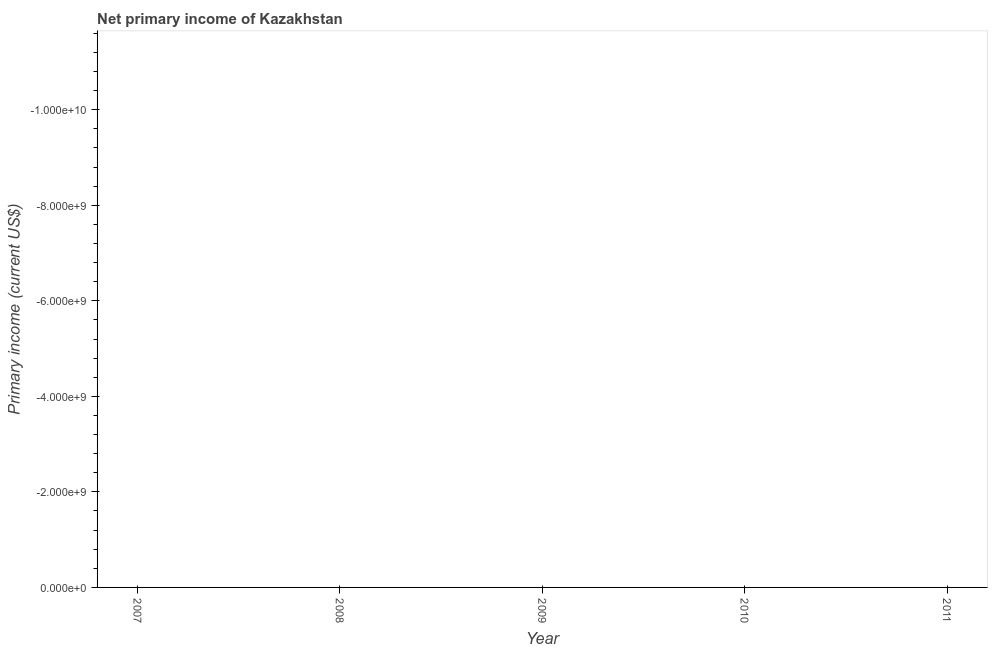What is the amount of primary income in 2008?
Your answer should be compact. 0. What is the average amount of primary income per year?
Your response must be concise. 0. In how many years, is the amount of primary income greater than -2800000000 US$?
Ensure brevity in your answer.  0. In how many years, is the amount of primary income greater than the average amount of primary income taken over all years?
Your answer should be compact. 0. Does the amount of primary income monotonically increase over the years?
Give a very brief answer. No. How many dotlines are there?
Give a very brief answer. 0. What is the difference between two consecutive major ticks on the Y-axis?
Offer a very short reply. 2.00e+09. Does the graph contain any zero values?
Provide a short and direct response. Yes. What is the title of the graph?
Offer a terse response. Net primary income of Kazakhstan. What is the label or title of the X-axis?
Give a very brief answer. Year. What is the label or title of the Y-axis?
Your answer should be compact. Primary income (current US$). What is the Primary income (current US$) in 2007?
Your response must be concise. 0. What is the Primary income (current US$) in 2008?
Offer a terse response. 0. What is the Primary income (current US$) in 2009?
Offer a terse response. 0. What is the Primary income (current US$) in 2011?
Ensure brevity in your answer.  0. 